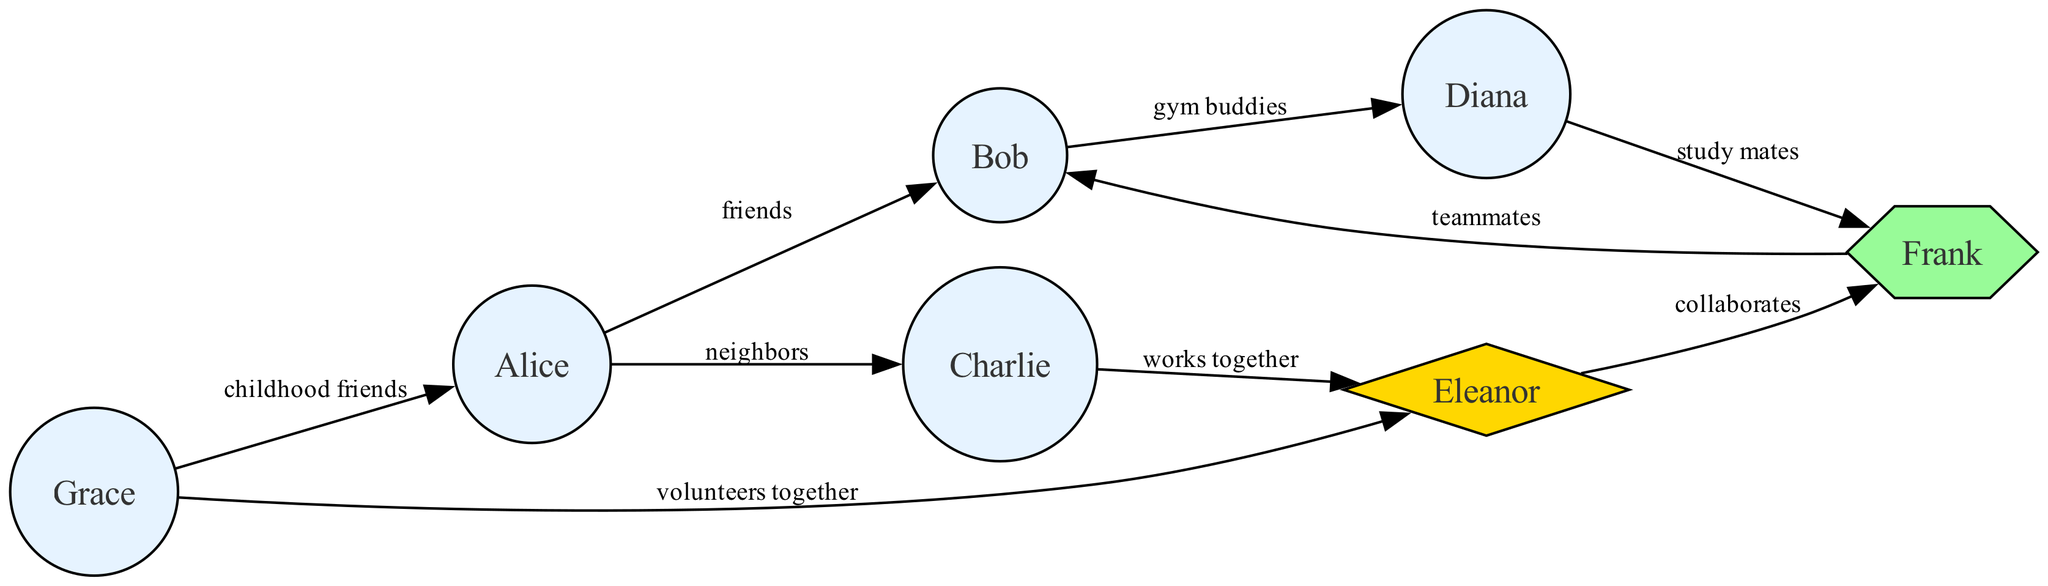What is the total number of nodes in the diagram? The diagram consists of multiple nodes representing people in the community. By counting all the nodes listed, we find that there are seven nodes in total: Alice, Bob, Charlie, Diana, Eleanor, Frank, and Grace.
Answer: 7 Who are the key connectors in the network? From the diagram, a key connector is defined as someone who has significant connections to multiple other nodes. The node labeled as 'Key Connector' is Frank, as he connects to Bob and Diana while being connected to Eleanor as well.
Answer: Frank How many edges originate from Eleanor? To determine the number of edges originating from Eleanor, we count the connections that start from this node. Eleanor has two edges going to Frank and Charlie, which means there are two outgoing edges.
Answer: 2 What type of relationship exists between Charlie and Eleanor? By examining the connecting edges in the diagram, we see that Charlie and Eleanor have a 'works together' relationship. This is explicitly labeled on the diagram as the connection between these two nodes.
Answer: works together Which neighbor has the most connections? To identify the neighbor with the most connections, we review the edges associated with the 'Neighbor' roles. Bob, who is connected to Alice, Diana, and Frank forms three connections, making him the neighbor with the most interactions.
Answer: Bob Which two individuals are connected as childhood friends? From the diagram, the edge connected to 'childhood friends' clearly indicates the connection between Grace and Alice. This relationship indicates a long-term acquaintance dating from their earlier years.
Answer: Grace and Alice Who volunteers together in the community? The diagram shows a connection labeled 'volunteers together' between Grace and Eleanor. This indicates that they have a collaborative relationship in community service activities.
Answer: Grace and Eleanor What role does Frank play in the social network? Frank is identified as a 'Key Connector' in the diagram, showing he plays a crucial role in linking different members of the community through his relationships.
Answer: Key Connector 